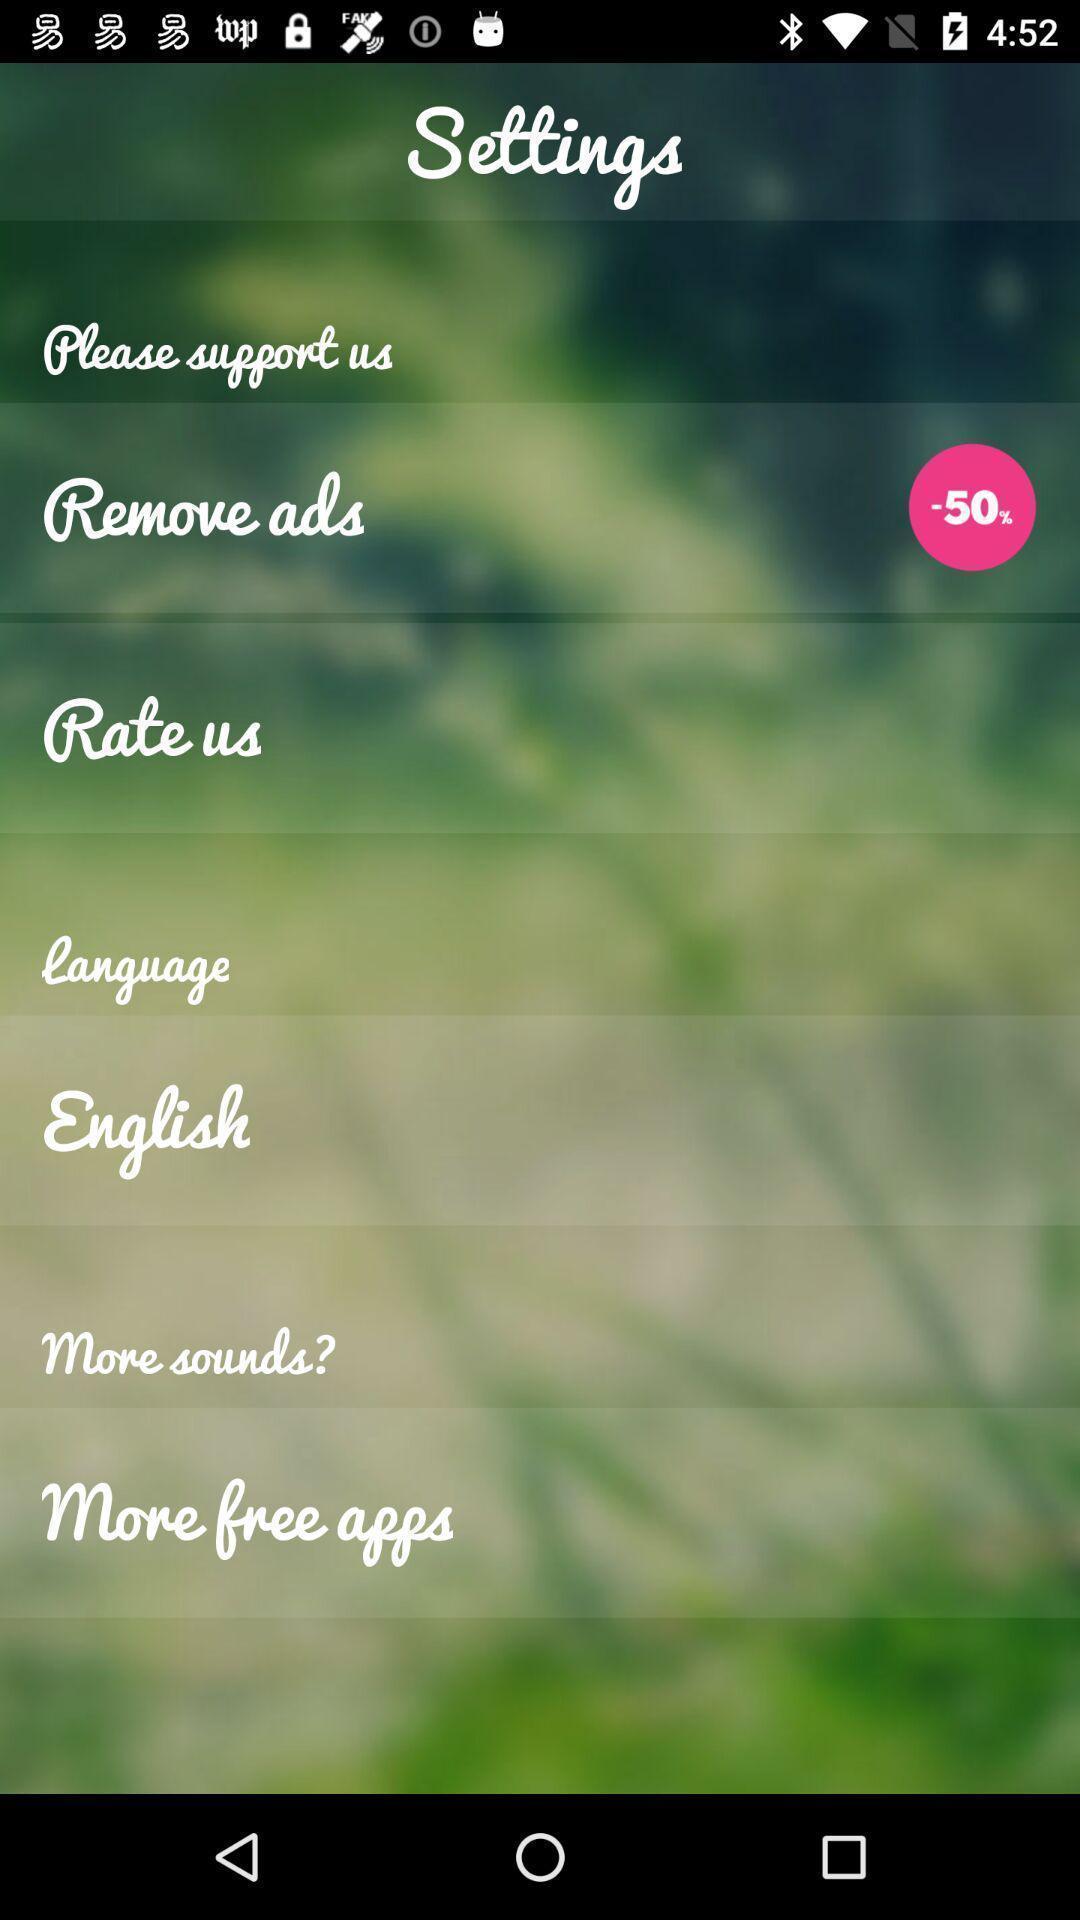What is the overall content of this screenshot? Settings page displaying various options. 